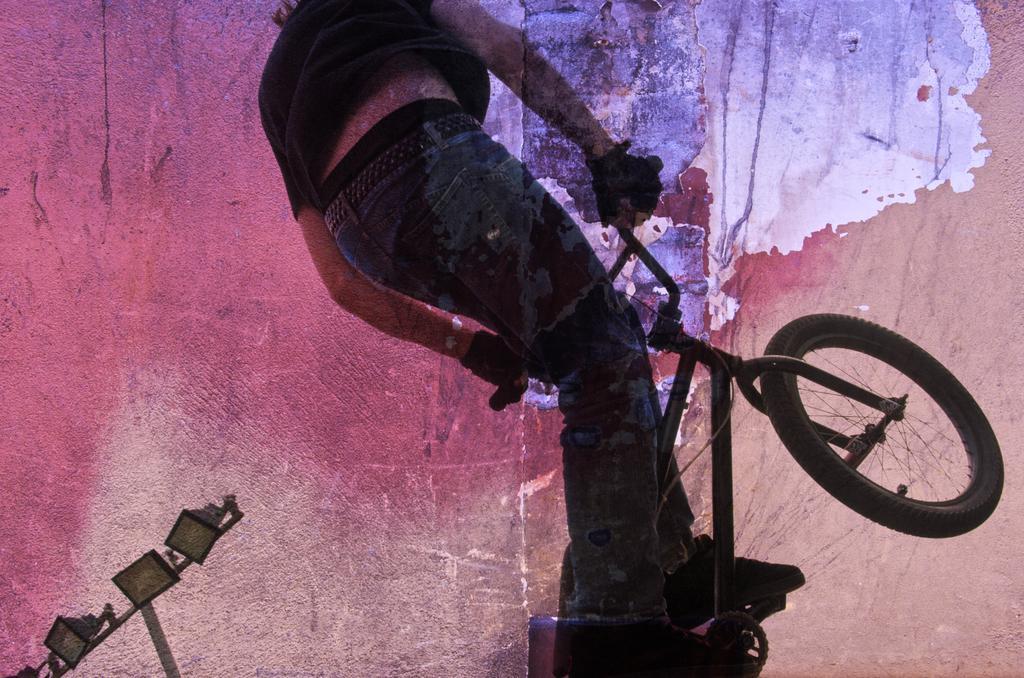Could you give a brief overview of what you see in this image? This image is a painting. In this image we can see person and cycle. At the bottom left corner we can see lights. 